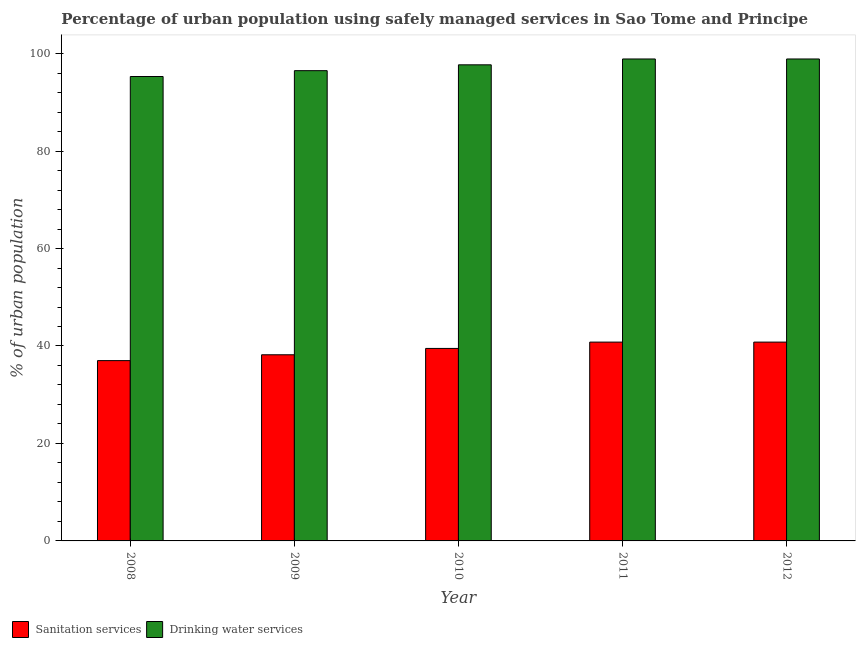How many different coloured bars are there?
Keep it short and to the point. 2. How many bars are there on the 4th tick from the left?
Make the answer very short. 2. How many bars are there on the 4th tick from the right?
Make the answer very short. 2. In how many cases, is the number of bars for a given year not equal to the number of legend labels?
Your answer should be compact. 0. What is the percentage of urban population who used sanitation services in 2010?
Give a very brief answer. 39.5. Across all years, what is the maximum percentage of urban population who used sanitation services?
Give a very brief answer. 40.8. Across all years, what is the minimum percentage of urban population who used drinking water services?
Your response must be concise. 95.3. In which year was the percentage of urban population who used drinking water services maximum?
Provide a succinct answer. 2011. What is the total percentage of urban population who used drinking water services in the graph?
Your answer should be very brief. 487.3. What is the difference between the percentage of urban population who used sanitation services in 2008 and that in 2010?
Your answer should be very brief. -2.5. What is the difference between the percentage of urban population who used sanitation services in 2012 and the percentage of urban population who used drinking water services in 2008?
Make the answer very short. 3.8. What is the average percentage of urban population who used drinking water services per year?
Offer a terse response. 97.46. In the year 2010, what is the difference between the percentage of urban population who used drinking water services and percentage of urban population who used sanitation services?
Offer a terse response. 0. What is the ratio of the percentage of urban population who used sanitation services in 2008 to that in 2012?
Offer a terse response. 0.91. Is the percentage of urban population who used sanitation services in 2008 less than that in 2010?
Make the answer very short. Yes. What is the difference between the highest and the second highest percentage of urban population who used sanitation services?
Provide a short and direct response. 0. What is the difference between the highest and the lowest percentage of urban population who used drinking water services?
Make the answer very short. 3.6. In how many years, is the percentage of urban population who used drinking water services greater than the average percentage of urban population who used drinking water services taken over all years?
Offer a terse response. 3. What does the 1st bar from the left in 2008 represents?
Make the answer very short. Sanitation services. What does the 2nd bar from the right in 2008 represents?
Provide a succinct answer. Sanitation services. How many bars are there?
Provide a succinct answer. 10. How many years are there in the graph?
Keep it short and to the point. 5. Are the values on the major ticks of Y-axis written in scientific E-notation?
Your response must be concise. No. How many legend labels are there?
Your answer should be compact. 2. What is the title of the graph?
Offer a very short reply. Percentage of urban population using safely managed services in Sao Tome and Principe. Does "Net savings(excluding particulate emission damage)" appear as one of the legend labels in the graph?
Make the answer very short. No. What is the label or title of the Y-axis?
Provide a short and direct response. % of urban population. What is the % of urban population in Drinking water services in 2008?
Keep it short and to the point. 95.3. What is the % of urban population of Sanitation services in 2009?
Provide a succinct answer. 38.2. What is the % of urban population of Drinking water services in 2009?
Your response must be concise. 96.5. What is the % of urban population of Sanitation services in 2010?
Provide a short and direct response. 39.5. What is the % of urban population of Drinking water services in 2010?
Your answer should be compact. 97.7. What is the % of urban population of Sanitation services in 2011?
Make the answer very short. 40.8. What is the % of urban population of Drinking water services in 2011?
Your response must be concise. 98.9. What is the % of urban population of Sanitation services in 2012?
Make the answer very short. 40.8. What is the % of urban population of Drinking water services in 2012?
Give a very brief answer. 98.9. Across all years, what is the maximum % of urban population in Sanitation services?
Keep it short and to the point. 40.8. Across all years, what is the maximum % of urban population in Drinking water services?
Make the answer very short. 98.9. Across all years, what is the minimum % of urban population of Sanitation services?
Keep it short and to the point. 37. Across all years, what is the minimum % of urban population in Drinking water services?
Your response must be concise. 95.3. What is the total % of urban population of Sanitation services in the graph?
Offer a terse response. 196.3. What is the total % of urban population in Drinking water services in the graph?
Offer a terse response. 487.3. What is the difference between the % of urban population in Sanitation services in 2008 and that in 2009?
Make the answer very short. -1.2. What is the difference between the % of urban population of Drinking water services in 2008 and that in 2010?
Provide a short and direct response. -2.4. What is the difference between the % of urban population in Sanitation services in 2008 and that in 2011?
Offer a terse response. -3.8. What is the difference between the % of urban population in Drinking water services in 2008 and that in 2011?
Make the answer very short. -3.6. What is the difference between the % of urban population of Drinking water services in 2008 and that in 2012?
Make the answer very short. -3.6. What is the difference between the % of urban population of Drinking water services in 2009 and that in 2010?
Give a very brief answer. -1.2. What is the difference between the % of urban population in Sanitation services in 2009 and that in 2011?
Give a very brief answer. -2.6. What is the difference between the % of urban population of Drinking water services in 2009 and that in 2011?
Your answer should be very brief. -2.4. What is the difference between the % of urban population of Sanitation services in 2010 and that in 2011?
Provide a succinct answer. -1.3. What is the difference between the % of urban population of Sanitation services in 2010 and that in 2012?
Your answer should be compact. -1.3. What is the difference between the % of urban population in Drinking water services in 2010 and that in 2012?
Your answer should be very brief. -1.2. What is the difference between the % of urban population of Sanitation services in 2011 and that in 2012?
Give a very brief answer. 0. What is the difference between the % of urban population of Sanitation services in 2008 and the % of urban population of Drinking water services in 2009?
Keep it short and to the point. -59.5. What is the difference between the % of urban population of Sanitation services in 2008 and the % of urban population of Drinking water services in 2010?
Your answer should be very brief. -60.7. What is the difference between the % of urban population in Sanitation services in 2008 and the % of urban population in Drinking water services in 2011?
Make the answer very short. -61.9. What is the difference between the % of urban population of Sanitation services in 2008 and the % of urban population of Drinking water services in 2012?
Give a very brief answer. -61.9. What is the difference between the % of urban population in Sanitation services in 2009 and the % of urban population in Drinking water services in 2010?
Make the answer very short. -59.5. What is the difference between the % of urban population in Sanitation services in 2009 and the % of urban population in Drinking water services in 2011?
Give a very brief answer. -60.7. What is the difference between the % of urban population in Sanitation services in 2009 and the % of urban population in Drinking water services in 2012?
Keep it short and to the point. -60.7. What is the difference between the % of urban population in Sanitation services in 2010 and the % of urban population in Drinking water services in 2011?
Give a very brief answer. -59.4. What is the difference between the % of urban population of Sanitation services in 2010 and the % of urban population of Drinking water services in 2012?
Provide a short and direct response. -59.4. What is the difference between the % of urban population of Sanitation services in 2011 and the % of urban population of Drinking water services in 2012?
Ensure brevity in your answer.  -58.1. What is the average % of urban population of Sanitation services per year?
Keep it short and to the point. 39.26. What is the average % of urban population in Drinking water services per year?
Provide a short and direct response. 97.46. In the year 2008, what is the difference between the % of urban population of Sanitation services and % of urban population of Drinking water services?
Give a very brief answer. -58.3. In the year 2009, what is the difference between the % of urban population in Sanitation services and % of urban population in Drinking water services?
Offer a terse response. -58.3. In the year 2010, what is the difference between the % of urban population in Sanitation services and % of urban population in Drinking water services?
Your answer should be very brief. -58.2. In the year 2011, what is the difference between the % of urban population of Sanitation services and % of urban population of Drinking water services?
Offer a very short reply. -58.1. In the year 2012, what is the difference between the % of urban population in Sanitation services and % of urban population in Drinking water services?
Offer a terse response. -58.1. What is the ratio of the % of urban population in Sanitation services in 2008 to that in 2009?
Offer a very short reply. 0.97. What is the ratio of the % of urban population of Drinking water services in 2008 to that in 2009?
Provide a succinct answer. 0.99. What is the ratio of the % of urban population of Sanitation services in 2008 to that in 2010?
Your answer should be very brief. 0.94. What is the ratio of the % of urban population of Drinking water services in 2008 to that in 2010?
Your answer should be compact. 0.98. What is the ratio of the % of urban population in Sanitation services in 2008 to that in 2011?
Your response must be concise. 0.91. What is the ratio of the % of urban population of Drinking water services in 2008 to that in 2011?
Provide a succinct answer. 0.96. What is the ratio of the % of urban population of Sanitation services in 2008 to that in 2012?
Offer a very short reply. 0.91. What is the ratio of the % of urban population in Drinking water services in 2008 to that in 2012?
Offer a terse response. 0.96. What is the ratio of the % of urban population in Sanitation services in 2009 to that in 2010?
Your answer should be compact. 0.97. What is the ratio of the % of urban population in Sanitation services in 2009 to that in 2011?
Offer a very short reply. 0.94. What is the ratio of the % of urban population of Drinking water services in 2009 to that in 2011?
Offer a terse response. 0.98. What is the ratio of the % of urban population in Sanitation services in 2009 to that in 2012?
Ensure brevity in your answer.  0.94. What is the ratio of the % of urban population in Drinking water services in 2009 to that in 2012?
Make the answer very short. 0.98. What is the ratio of the % of urban population in Sanitation services in 2010 to that in 2011?
Ensure brevity in your answer.  0.97. What is the ratio of the % of urban population in Drinking water services in 2010 to that in 2011?
Your answer should be compact. 0.99. What is the ratio of the % of urban population of Sanitation services in 2010 to that in 2012?
Your answer should be very brief. 0.97. What is the ratio of the % of urban population of Drinking water services in 2010 to that in 2012?
Ensure brevity in your answer.  0.99. What is the difference between the highest and the second highest % of urban population in Sanitation services?
Ensure brevity in your answer.  0. What is the difference between the highest and the lowest % of urban population of Drinking water services?
Provide a succinct answer. 3.6. 